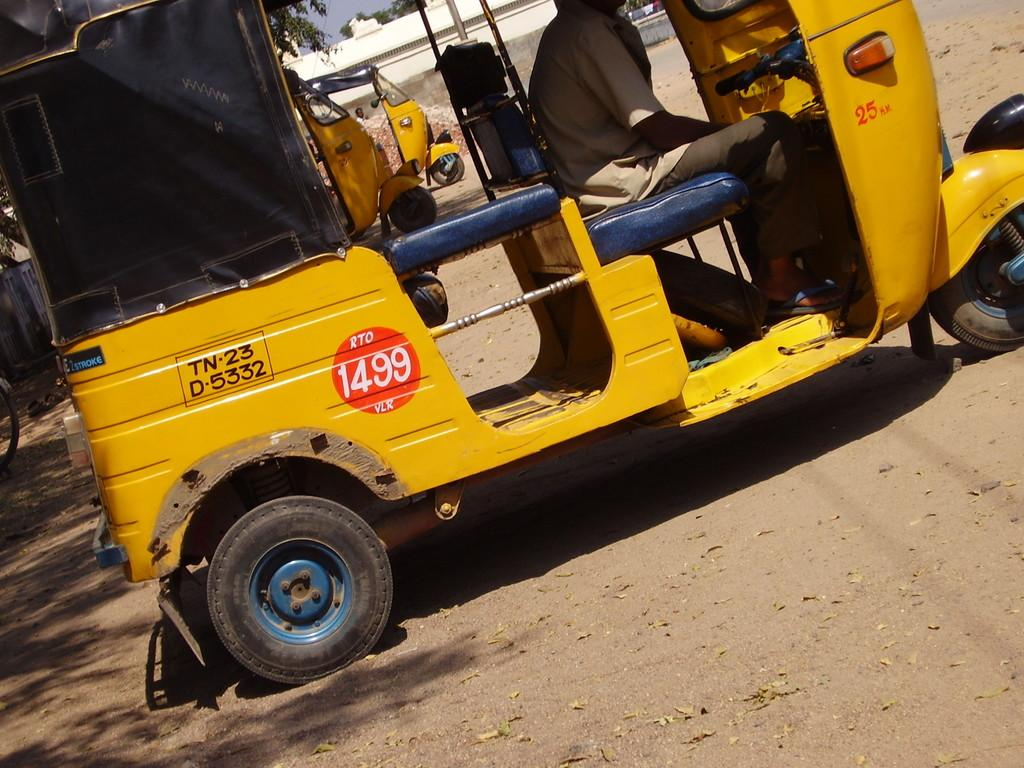What is present on the ground in the image? There are vehicles on the ground in the image. Can you describe the person in the image? There is a person in the image. What can be seen in the background of the image? There is a building and trees in the background of the image. What part of the natural environment is visible in the image? The sky is visible in the background of the image. How many family members are present in the image? There is no reference to a family or any family members in the image. What is the duration of the recess in the image? There is no indication of a recess or any time-related activity in the image. 